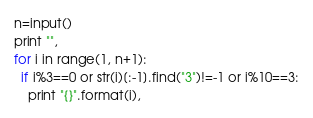Convert code to text. <code><loc_0><loc_0><loc_500><loc_500><_Python_>n=input()
print "",
for i in range(1, n+1):
  if i%3==0 or str(i)[:-1].find("3")!=-1 or i%10==3:
    print "{}".format(i),</code> 